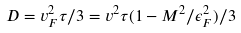Convert formula to latex. <formula><loc_0><loc_0><loc_500><loc_500>D = v _ { F } ^ { 2 } \tau / 3 = v ^ { 2 } \tau ( 1 - M ^ { 2 } / \epsilon _ { F } ^ { 2 } ) / 3</formula> 